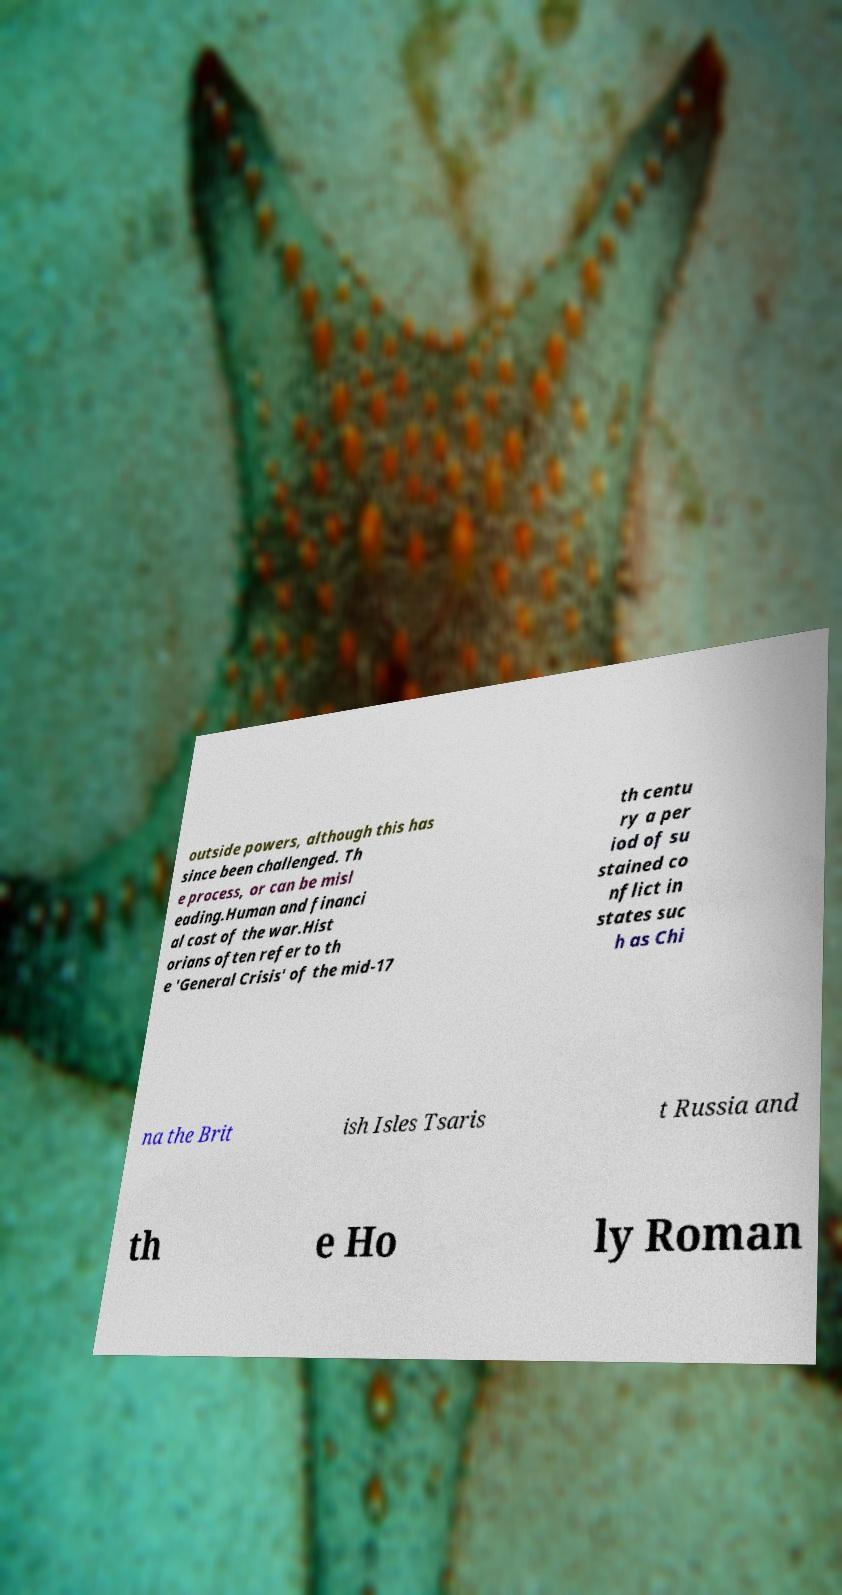I need the written content from this picture converted into text. Can you do that? outside powers, although this has since been challenged. Th e process, or can be misl eading.Human and financi al cost of the war.Hist orians often refer to th e 'General Crisis' of the mid-17 th centu ry a per iod of su stained co nflict in states suc h as Chi na the Brit ish Isles Tsaris t Russia and th e Ho ly Roman 